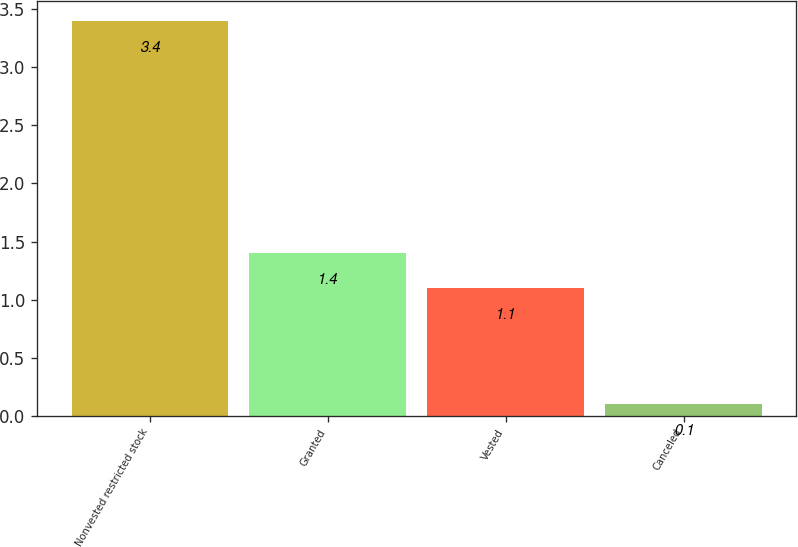Convert chart to OTSL. <chart><loc_0><loc_0><loc_500><loc_500><bar_chart><fcel>Nonvested restricted stock<fcel>Granted<fcel>Vested<fcel>Canceled<nl><fcel>3.4<fcel>1.4<fcel>1.1<fcel>0.1<nl></chart> 